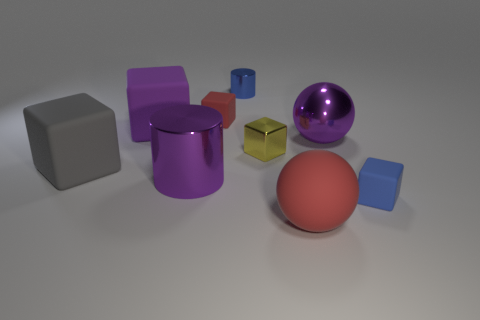Subtract 2 blocks. How many blocks are left? 3 Subtract all yellow cylinders. Subtract all purple spheres. How many cylinders are left? 2 Add 1 big purple metal objects. How many objects exist? 10 Subtract all balls. How many objects are left? 7 Subtract all metallic spheres. Subtract all big green rubber cylinders. How many objects are left? 8 Add 4 gray matte objects. How many gray matte objects are left? 5 Add 3 blue rubber blocks. How many blue rubber blocks exist? 4 Subtract 0 cyan cubes. How many objects are left? 9 